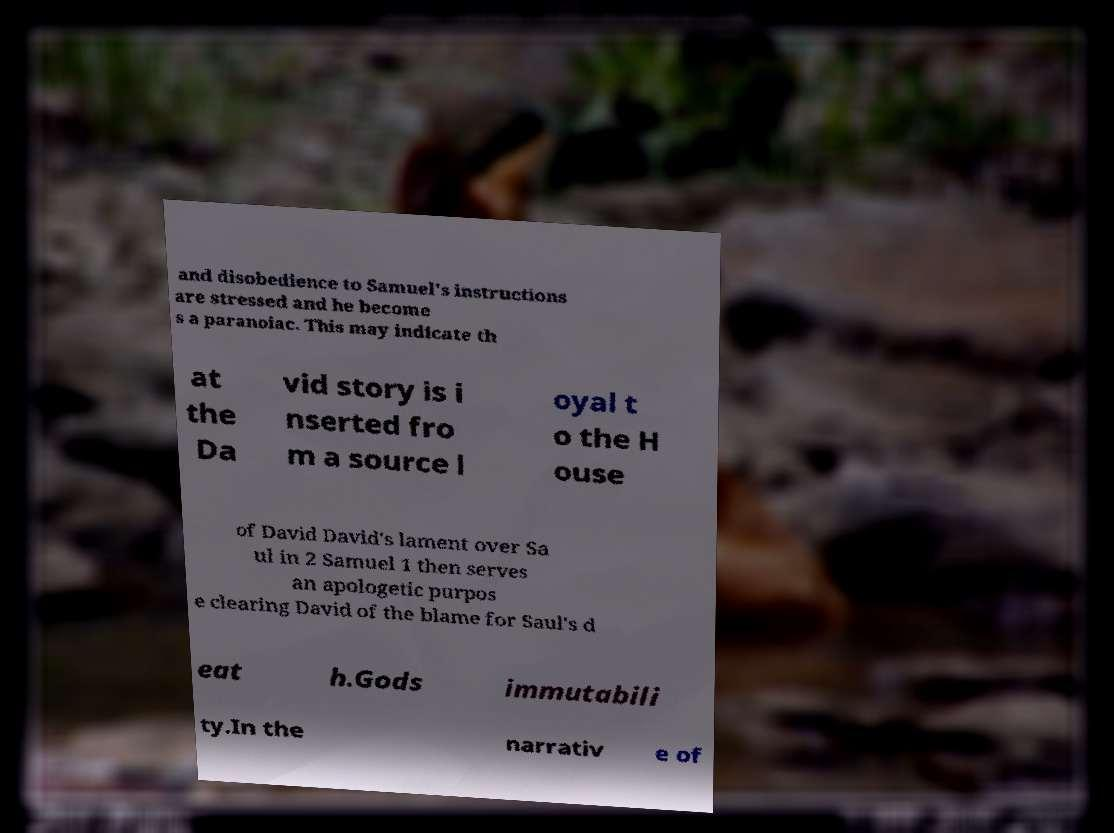Could you extract and type out the text from this image? and disobedience to Samuel's instructions are stressed and he become s a paranoiac. This may indicate th at the Da vid story is i nserted fro m a source l oyal t o the H ouse of David David's lament over Sa ul in 2 Samuel 1 then serves an apologetic purpos e clearing David of the blame for Saul's d eat h.Gods immutabili ty.In the narrativ e of 